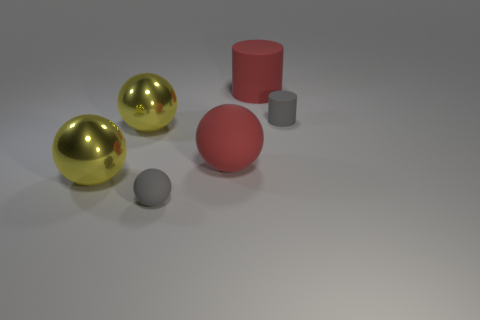There is a cylinder that is the same color as the large rubber ball; what material is it?
Offer a very short reply. Rubber. Is there a matte sphere that has the same color as the big matte cylinder?
Provide a succinct answer. Yes. How many balls are either matte things or tiny things?
Provide a succinct answer. 2. How many other things are the same color as the large cylinder?
Offer a terse response. 1. Is the number of small matte objects behind the gray cylinder less than the number of yellow shiny objects?
Your response must be concise. Yes. What number of gray spheres are there?
Offer a terse response. 1. How many big red spheres have the same material as the big red cylinder?
Your response must be concise. 1. What number of objects are gray rubber balls that are to the left of the large red sphere or big purple objects?
Make the answer very short. 1. Is the number of small gray rubber spheres that are in front of the tiny gray cylinder less than the number of things behind the tiny gray sphere?
Offer a very short reply. Yes. Are there any big rubber things in front of the large red cylinder?
Provide a succinct answer. Yes. 